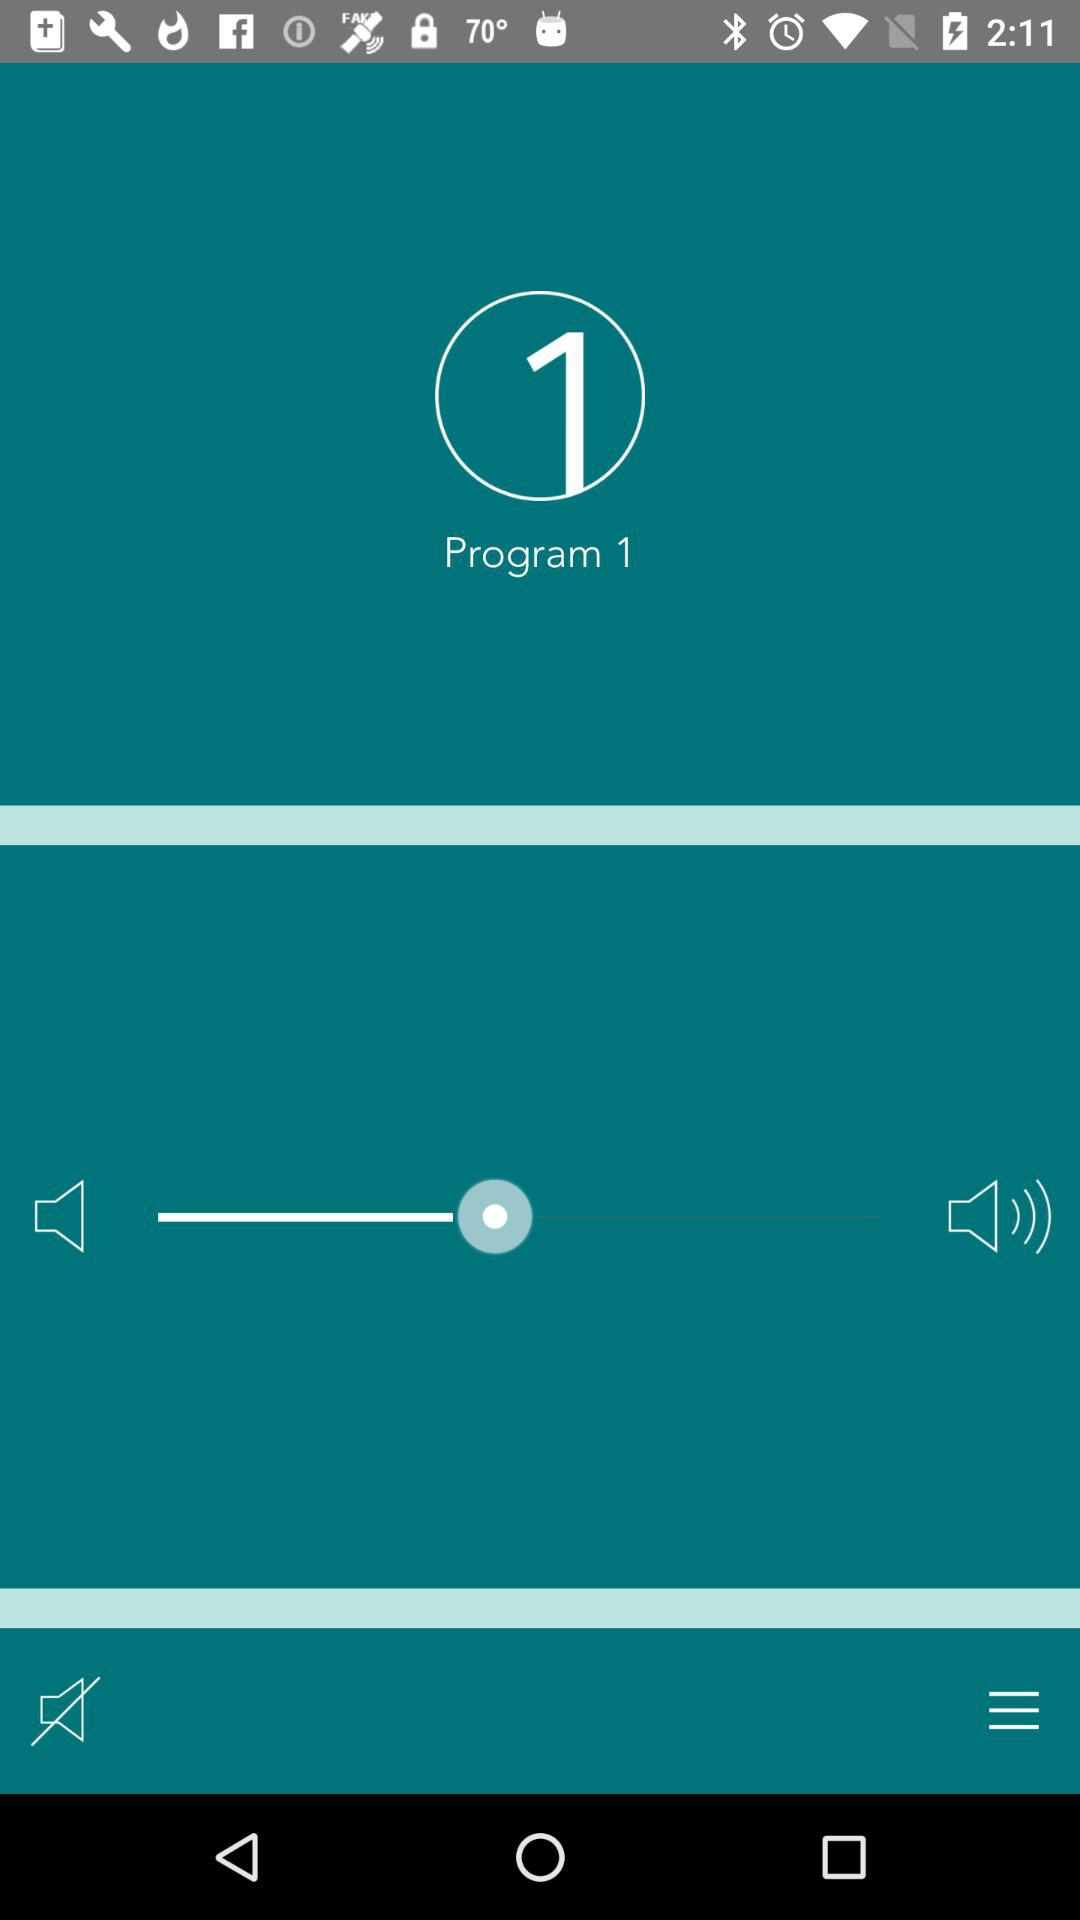How many volume states are there?
Answer the question using a single word or phrase. 2 